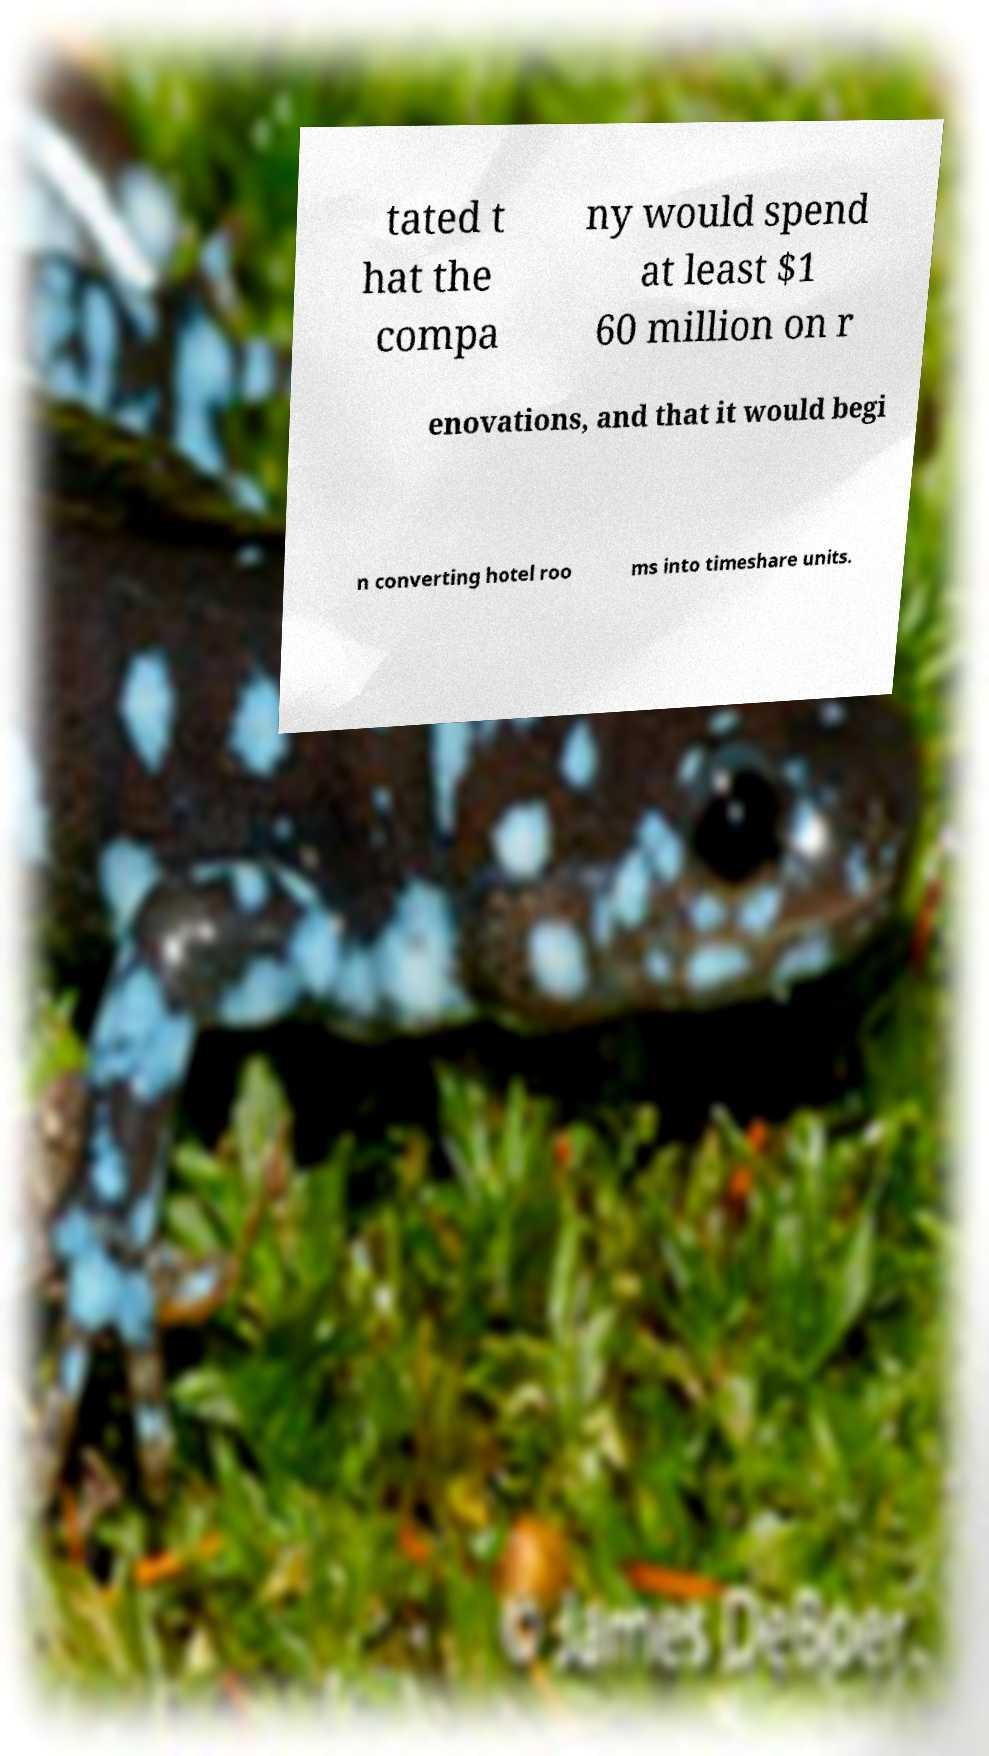Can you accurately transcribe the text from the provided image for me? tated t hat the compa ny would spend at least $1 60 million on r enovations, and that it would begi n converting hotel roo ms into timeshare units. 